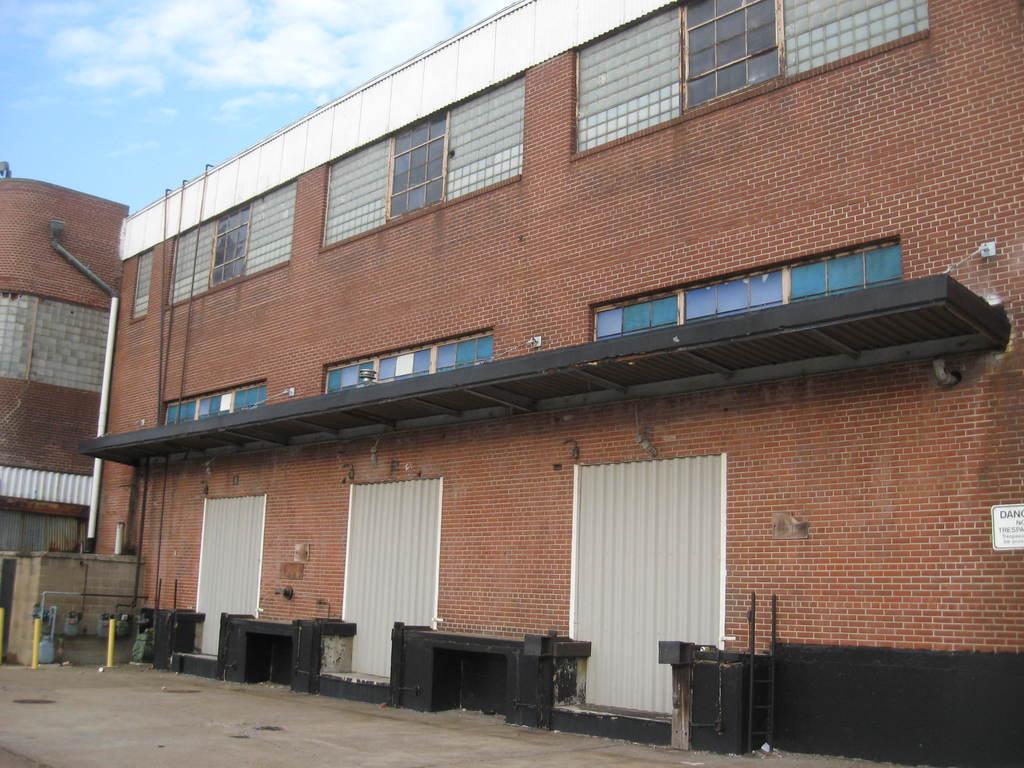Can you describe this image briefly? In this image I can see a building and on the right side of it I can see a white colour board on the wall. I can also see something is written on the board. On the left side of this image I can see two yellow colour poles. On the top left side of this image I can see clouds and the sky. 